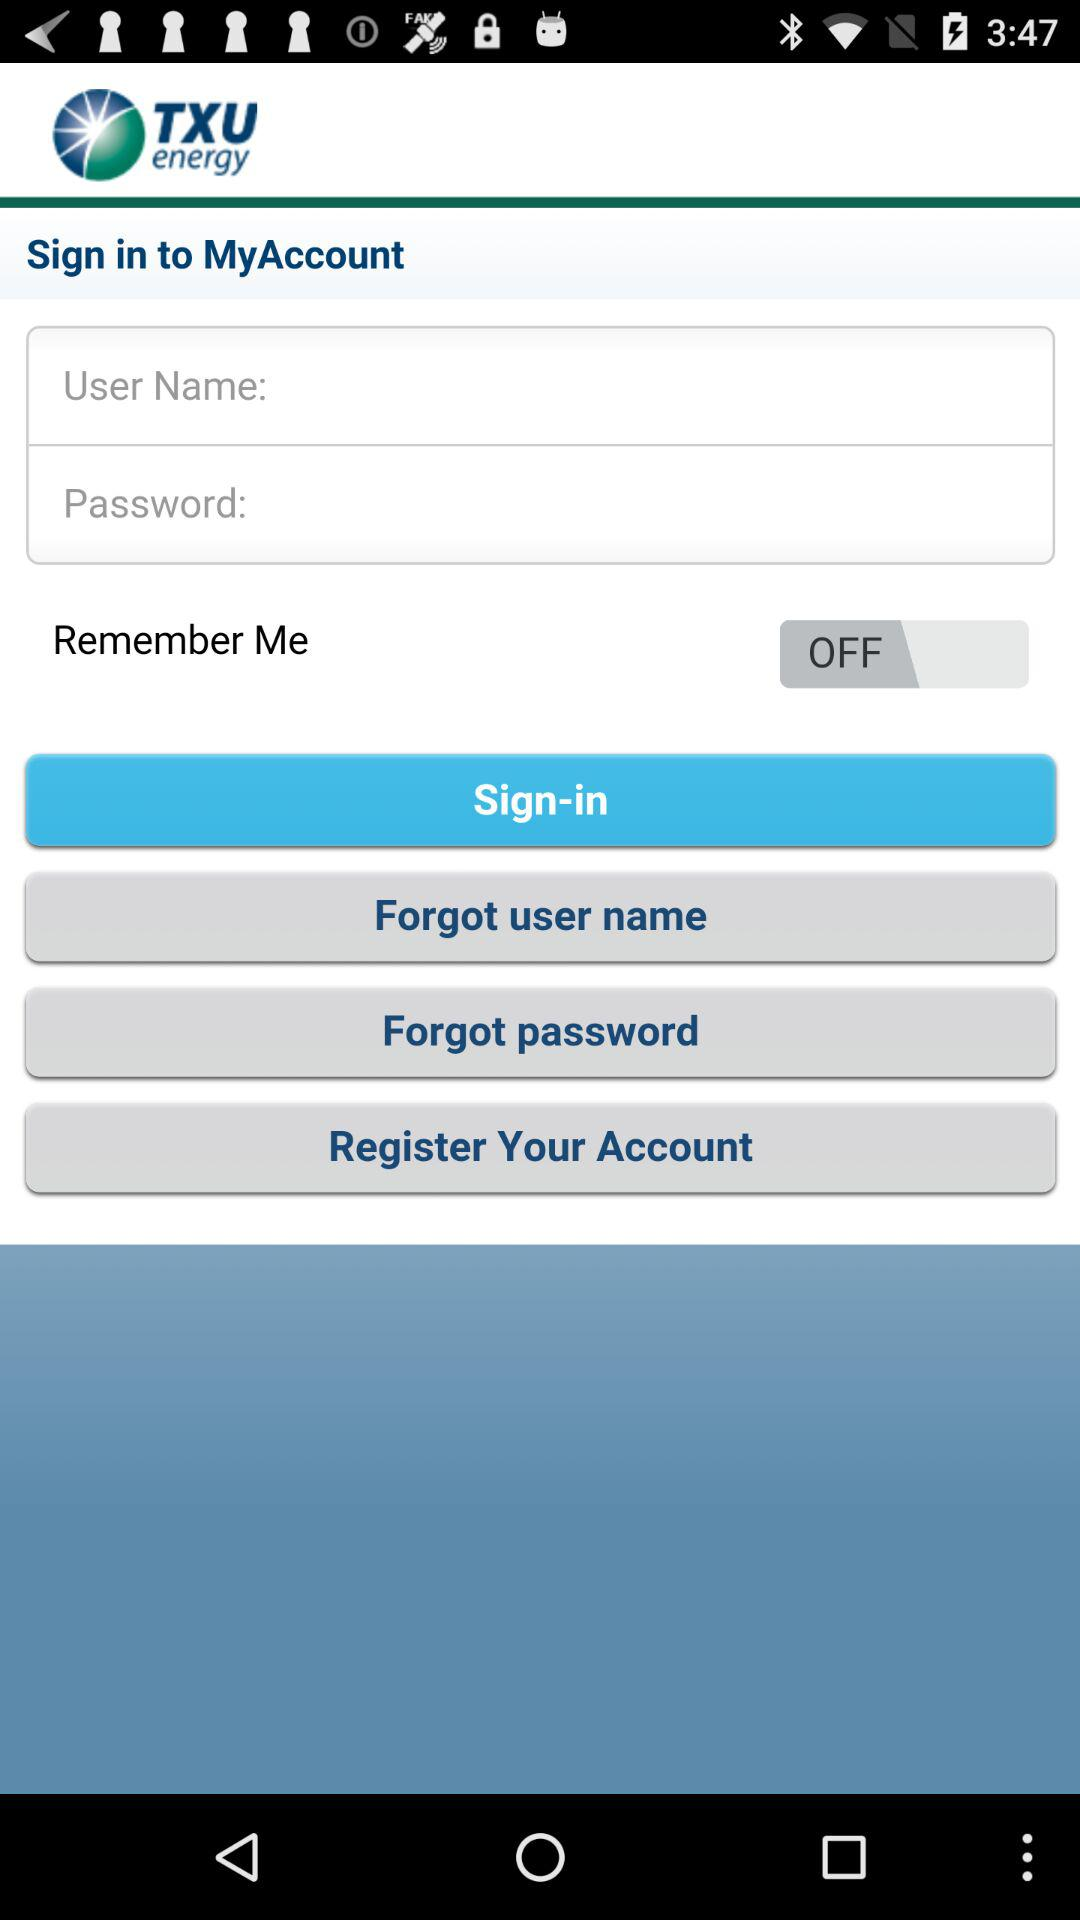What is the name of the application? The name of the application is "TXU energy". 